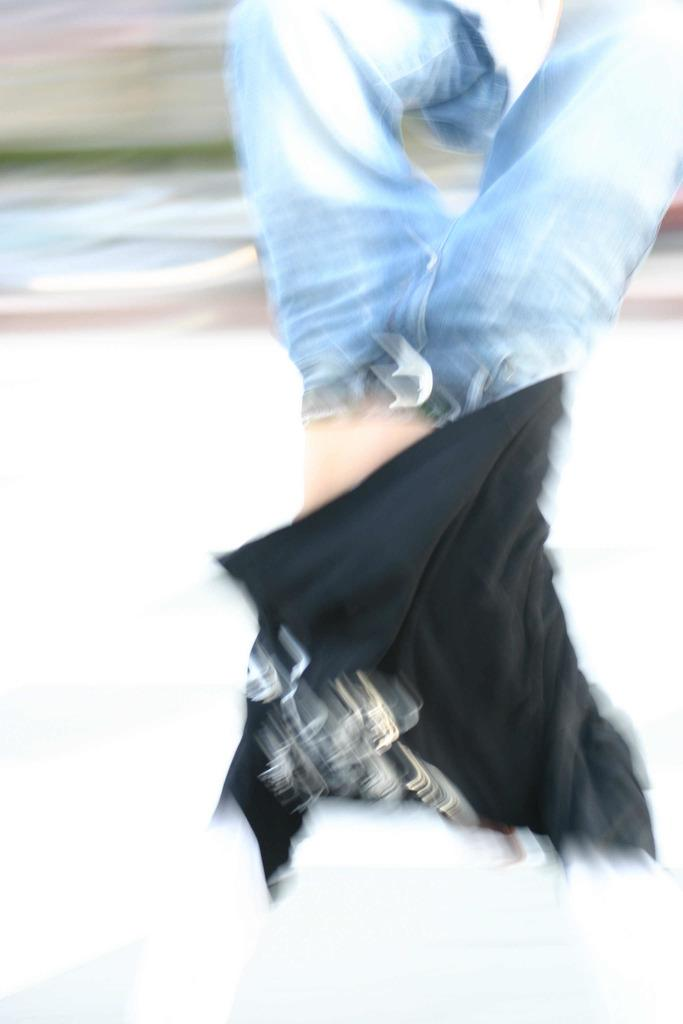Who is the main subject in the picture? The main subject in the picture is a boy. What is the boy wearing? The boy is wearing a black t-shirt. What is the boy doing in the picture? The boy is jumping and doing stunts. How is the background of the image depicted? The background of the image is blurred. What type of box is the boy using to perform his stunts in the image? There is no box present in the image; the boy is jumping and doing stunts without any visible props. 